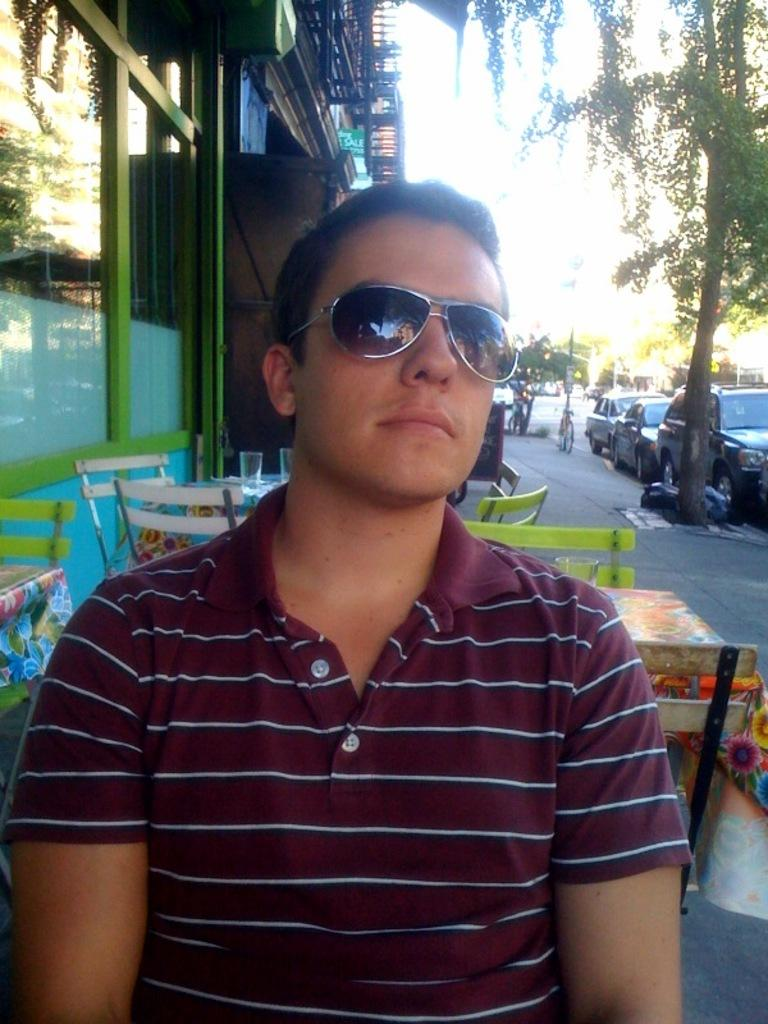Who is the main subject in the image? There is a man in the center of the image. What is the man wearing in the image? The man is wearing glasses in the image. What can be seen in the background of the image? There are tables, chairs, buildings, trees, and vehicles on the road in the background of the image. What type of cup is the man holding in the image? There is no cup present in the image; the man is not holding anything. 